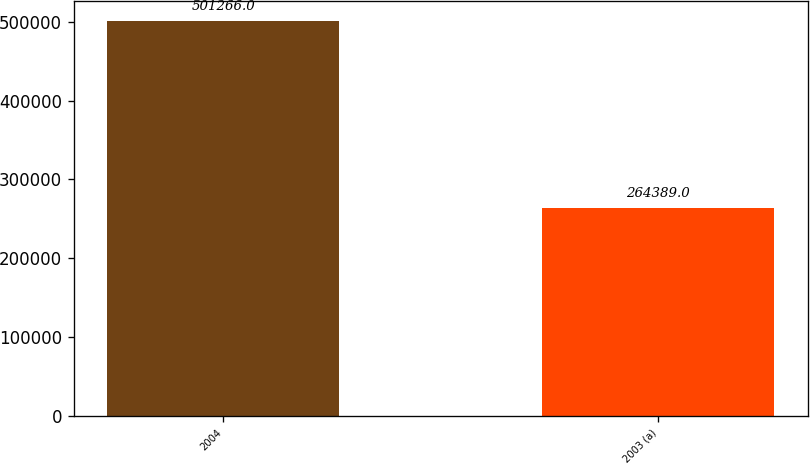Convert chart to OTSL. <chart><loc_0><loc_0><loc_500><loc_500><bar_chart><fcel>2004<fcel>2003 (a)<nl><fcel>501266<fcel>264389<nl></chart> 